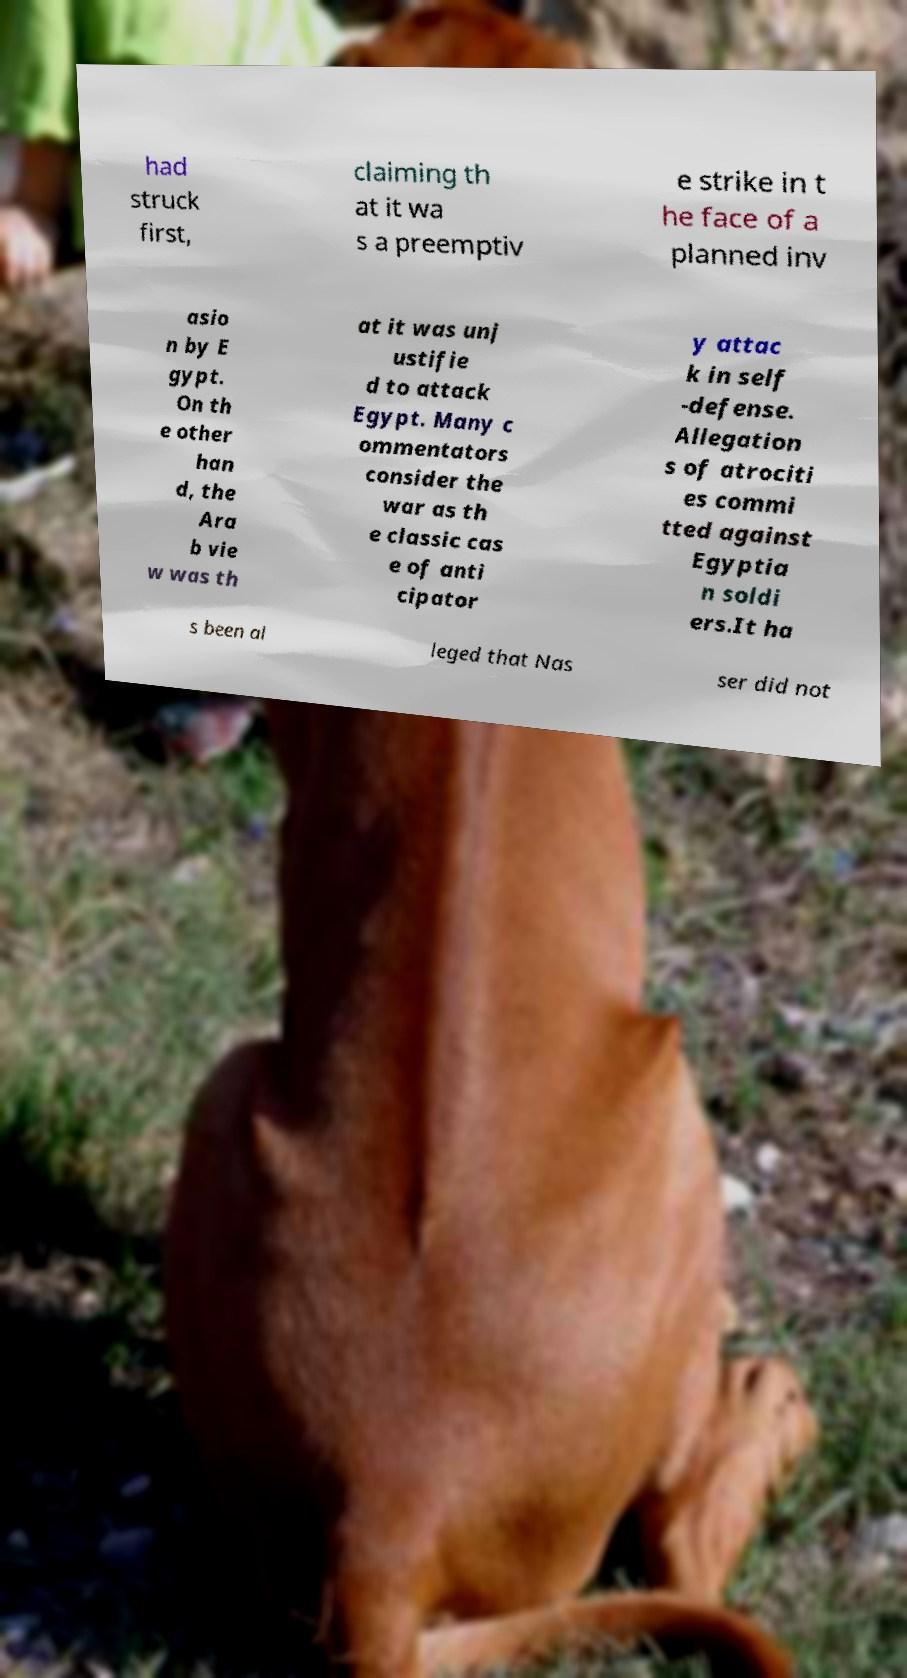Please identify and transcribe the text found in this image. had struck first, claiming th at it wa s a preemptiv e strike in t he face of a planned inv asio n by E gypt. On th e other han d, the Ara b vie w was th at it was unj ustifie d to attack Egypt. Many c ommentators consider the war as th e classic cas e of anti cipator y attac k in self -defense. Allegation s of atrociti es commi tted against Egyptia n soldi ers.It ha s been al leged that Nas ser did not 